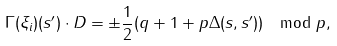Convert formula to latex. <formula><loc_0><loc_0><loc_500><loc_500>\Gamma ( \xi _ { i } ) ( s ^ { \prime } ) \cdot D = \pm \frac { 1 } { 2 } ( q + 1 + p \Delta ( s , s ^ { \prime } ) ) \mod p ,</formula> 